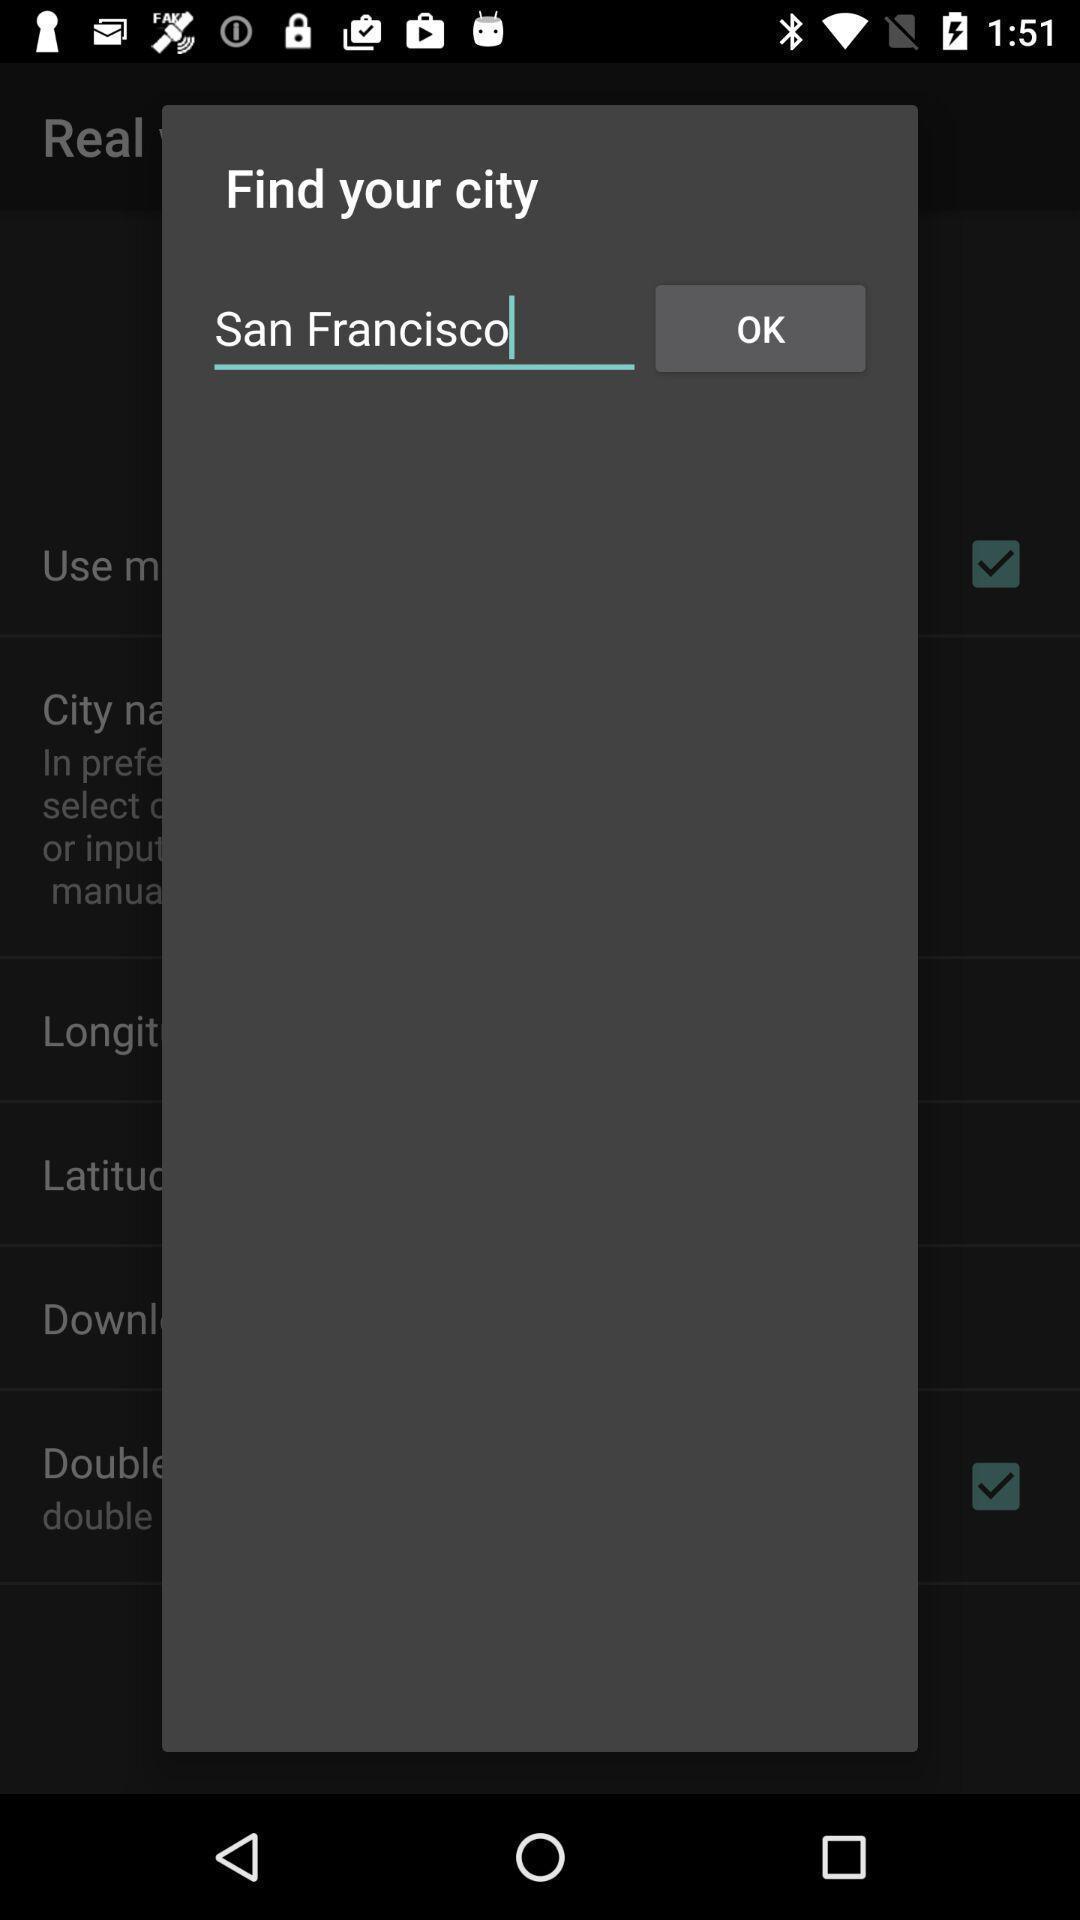Tell me about the visual elements in this screen capture. Popup showing options for select. 